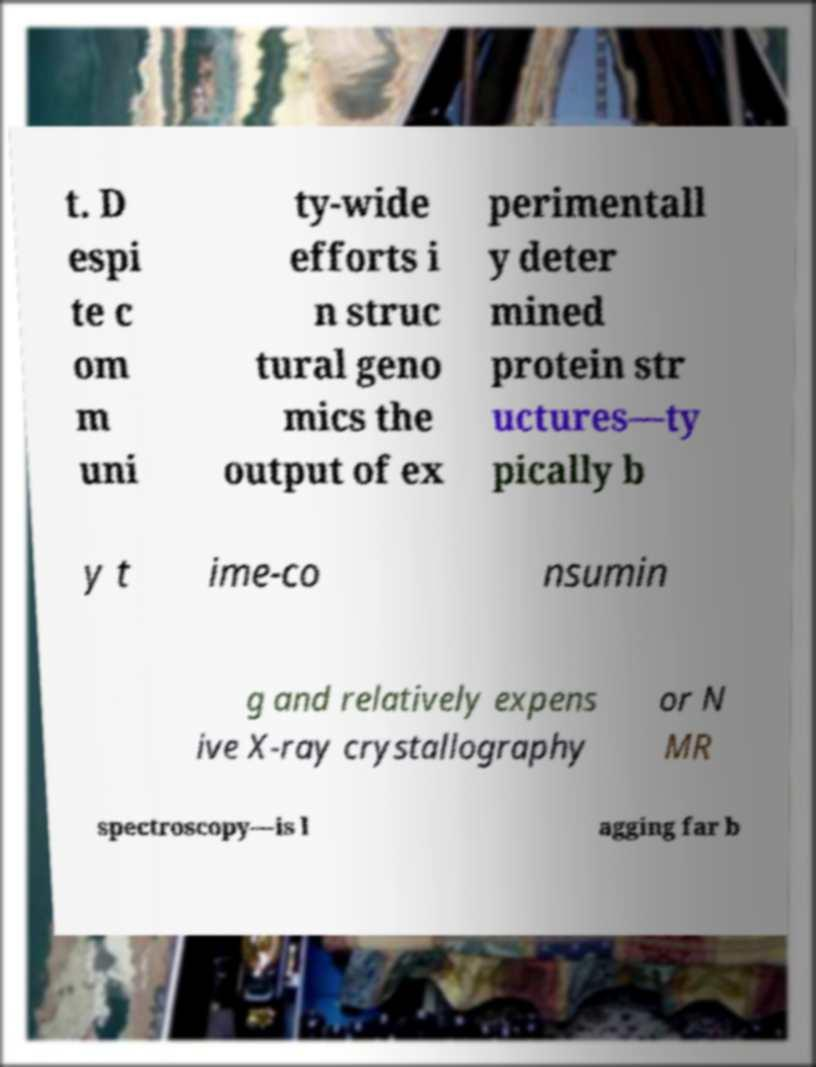Please read and relay the text visible in this image. What does it say? t. D espi te c om m uni ty-wide efforts i n struc tural geno mics the output of ex perimentall y deter mined protein str uctures—ty pically b y t ime-co nsumin g and relatively expens ive X-ray crystallography or N MR spectroscopy—is l agging far b 